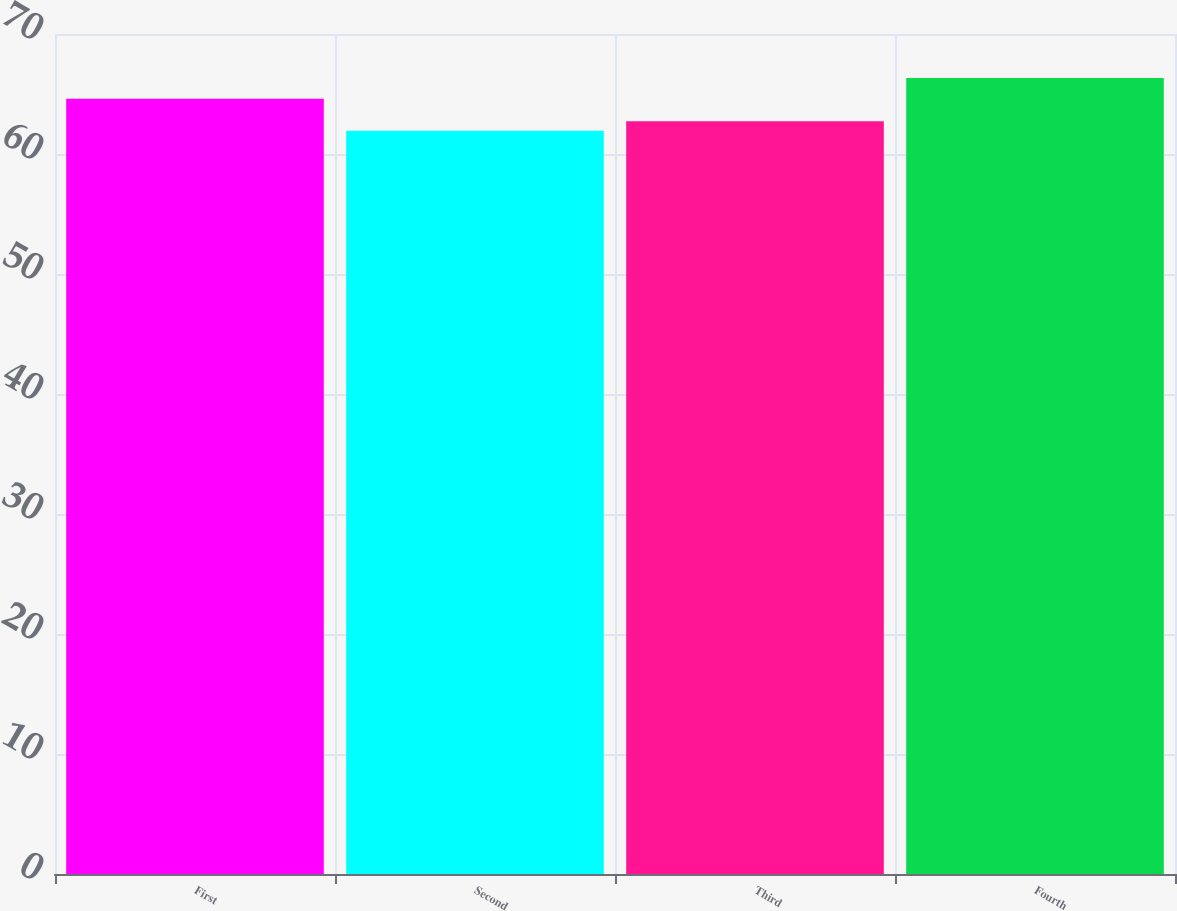<chart> <loc_0><loc_0><loc_500><loc_500><bar_chart><fcel>First<fcel>Second<fcel>Third<fcel>Fourth<nl><fcel>64.61<fcel>61.93<fcel>62.72<fcel>66.33<nl></chart> 